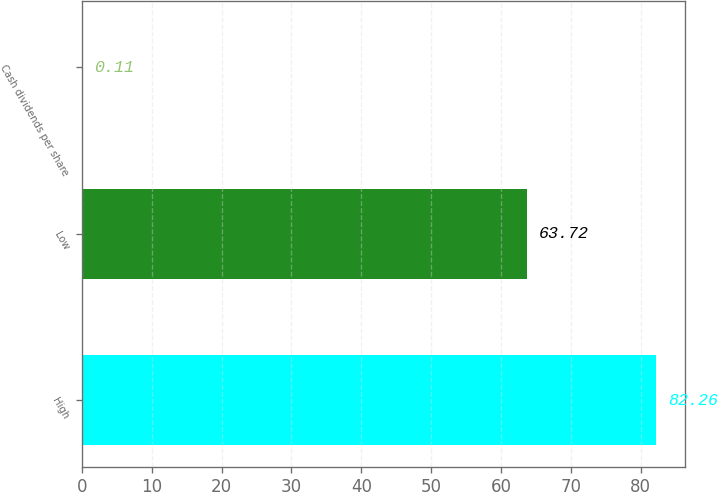<chart> <loc_0><loc_0><loc_500><loc_500><bar_chart><fcel>High<fcel>Low<fcel>Cash dividends per share<nl><fcel>82.26<fcel>63.72<fcel>0.11<nl></chart> 